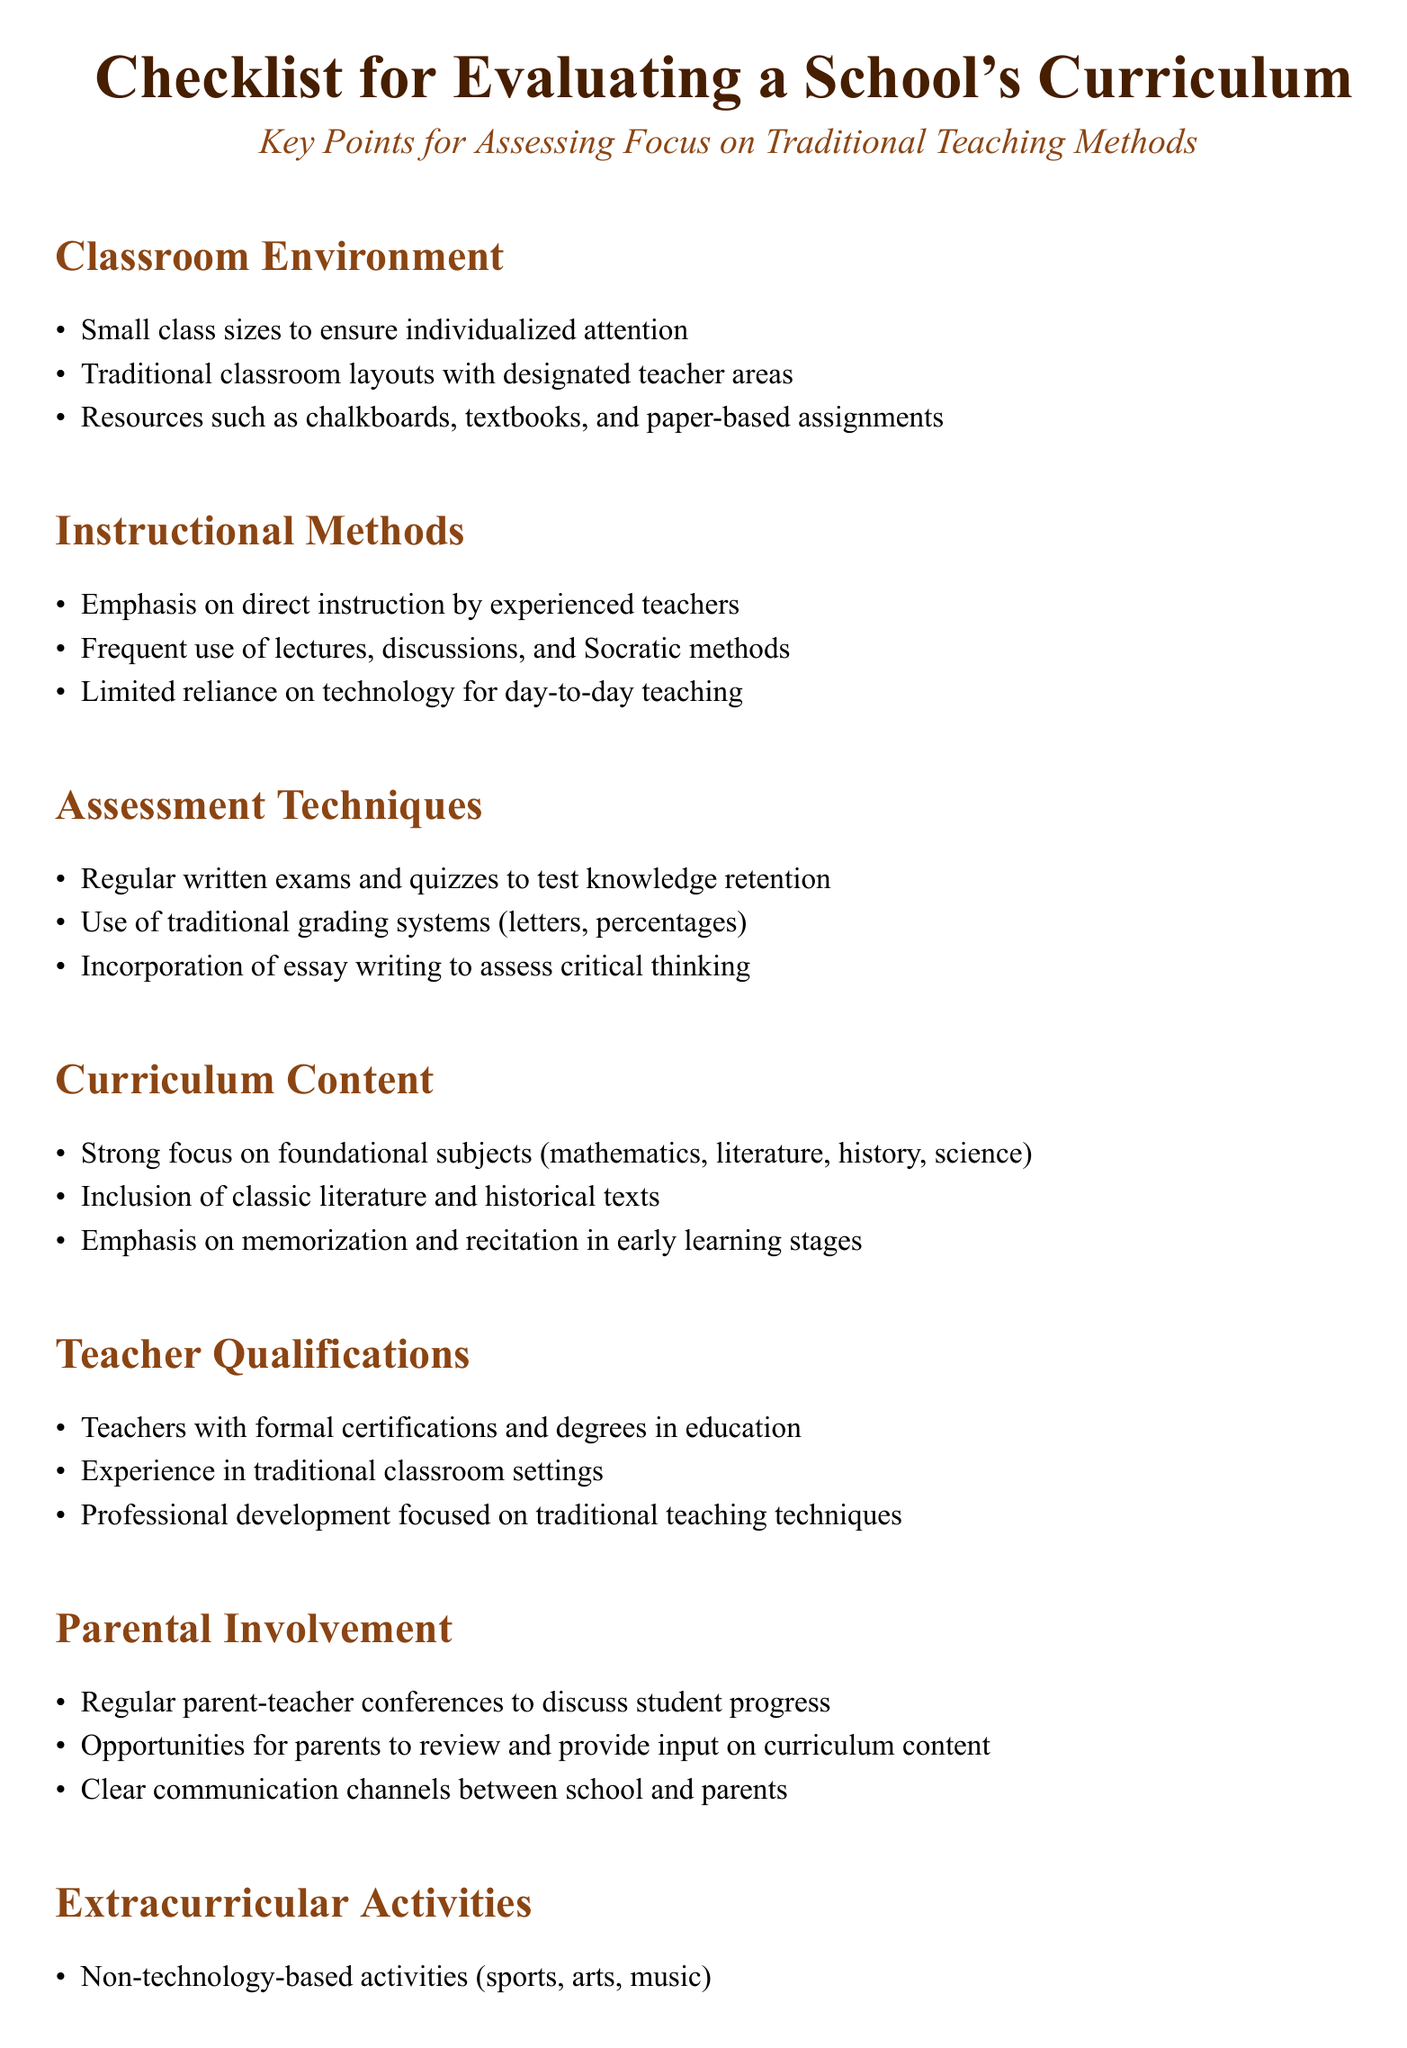What is a key feature of the classroom environment? The key feature mentioned is small class sizes to ensure individualized attention.
Answer: Small class sizes What method is emphasized in instructional techniques? The document indicates that there is an emphasis on direct instruction by experienced teachers.
Answer: Direct instruction What type of assessment is regularly used? The document highlights the use of regular written exams and quizzes to test knowledge retention.
Answer: Written exams What subjects are strongly focused on in the curriculum content? The document specifies a strong focus on foundational subjects such as mathematics, literature, history, and science.
Answer: Foundational subjects What is required of teachers according to the teacher qualifications section? The document states that teachers should have formal certifications and degrees in education.
Answer: Formal certifications How often are parent-teacher conferences held? The document suggests regular parent-teacher conferences to discuss student progress.
Answer: Regularly What type of activities are encouraged in extracurricular programs? The document emphasizes non-technology-based activities like sports, arts, and music.
Answer: Non-technology-based activities What discipline methods are mentioned in the classroom discipline section? The document refers to traditional discipline methods, such as detention.
Answer: Detention What is a document-specific detail to check regarding parent involvement? The document highlights opportunities for parents to review and provide input on curriculum content.
Answer: Opportunities for review 